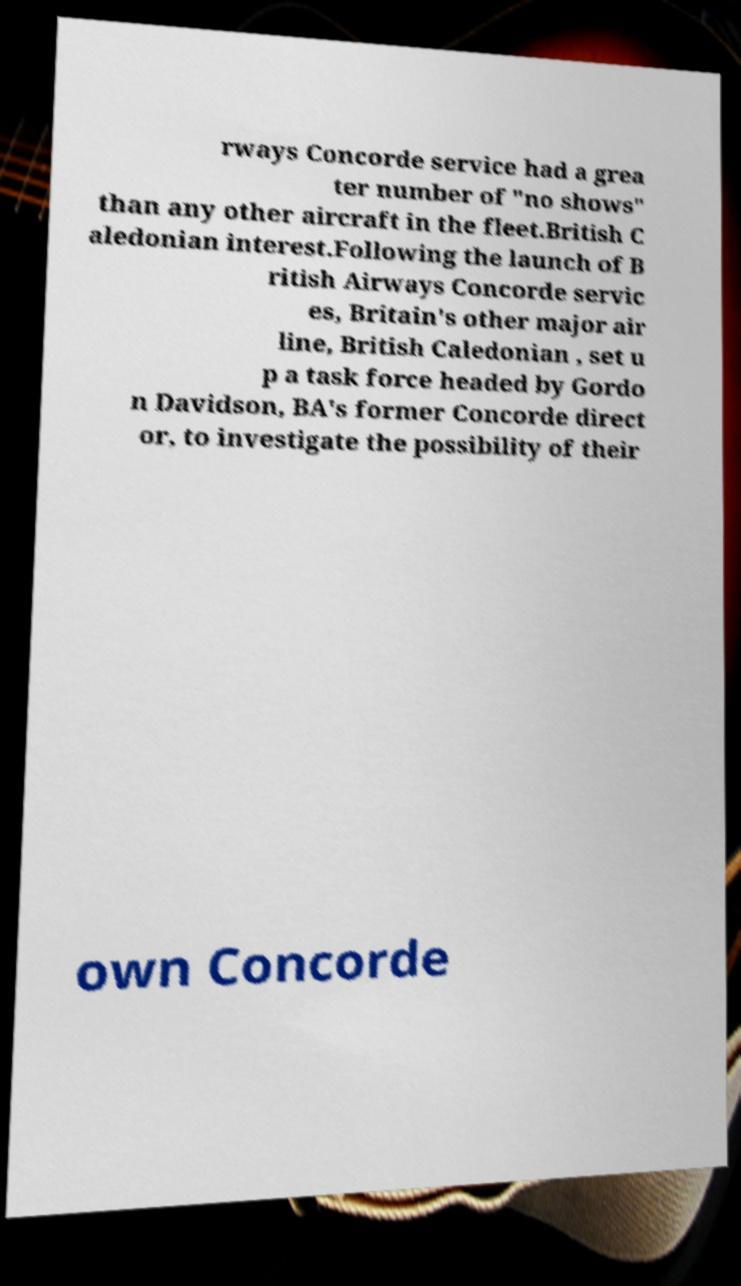Could you extract and type out the text from this image? rways Concorde service had a grea ter number of "no shows" than any other aircraft in the fleet.British C aledonian interest.Following the launch of B ritish Airways Concorde servic es, Britain's other major air line, British Caledonian , set u p a task force headed by Gordo n Davidson, BA's former Concorde direct or, to investigate the possibility of their own Concorde 